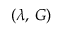<formula> <loc_0><loc_0><loc_500><loc_500>( \lambda , \, G )</formula> 